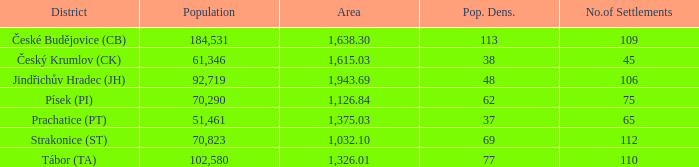How many settlements are in český krumlov (ck) with a population density higher than 38? None. 